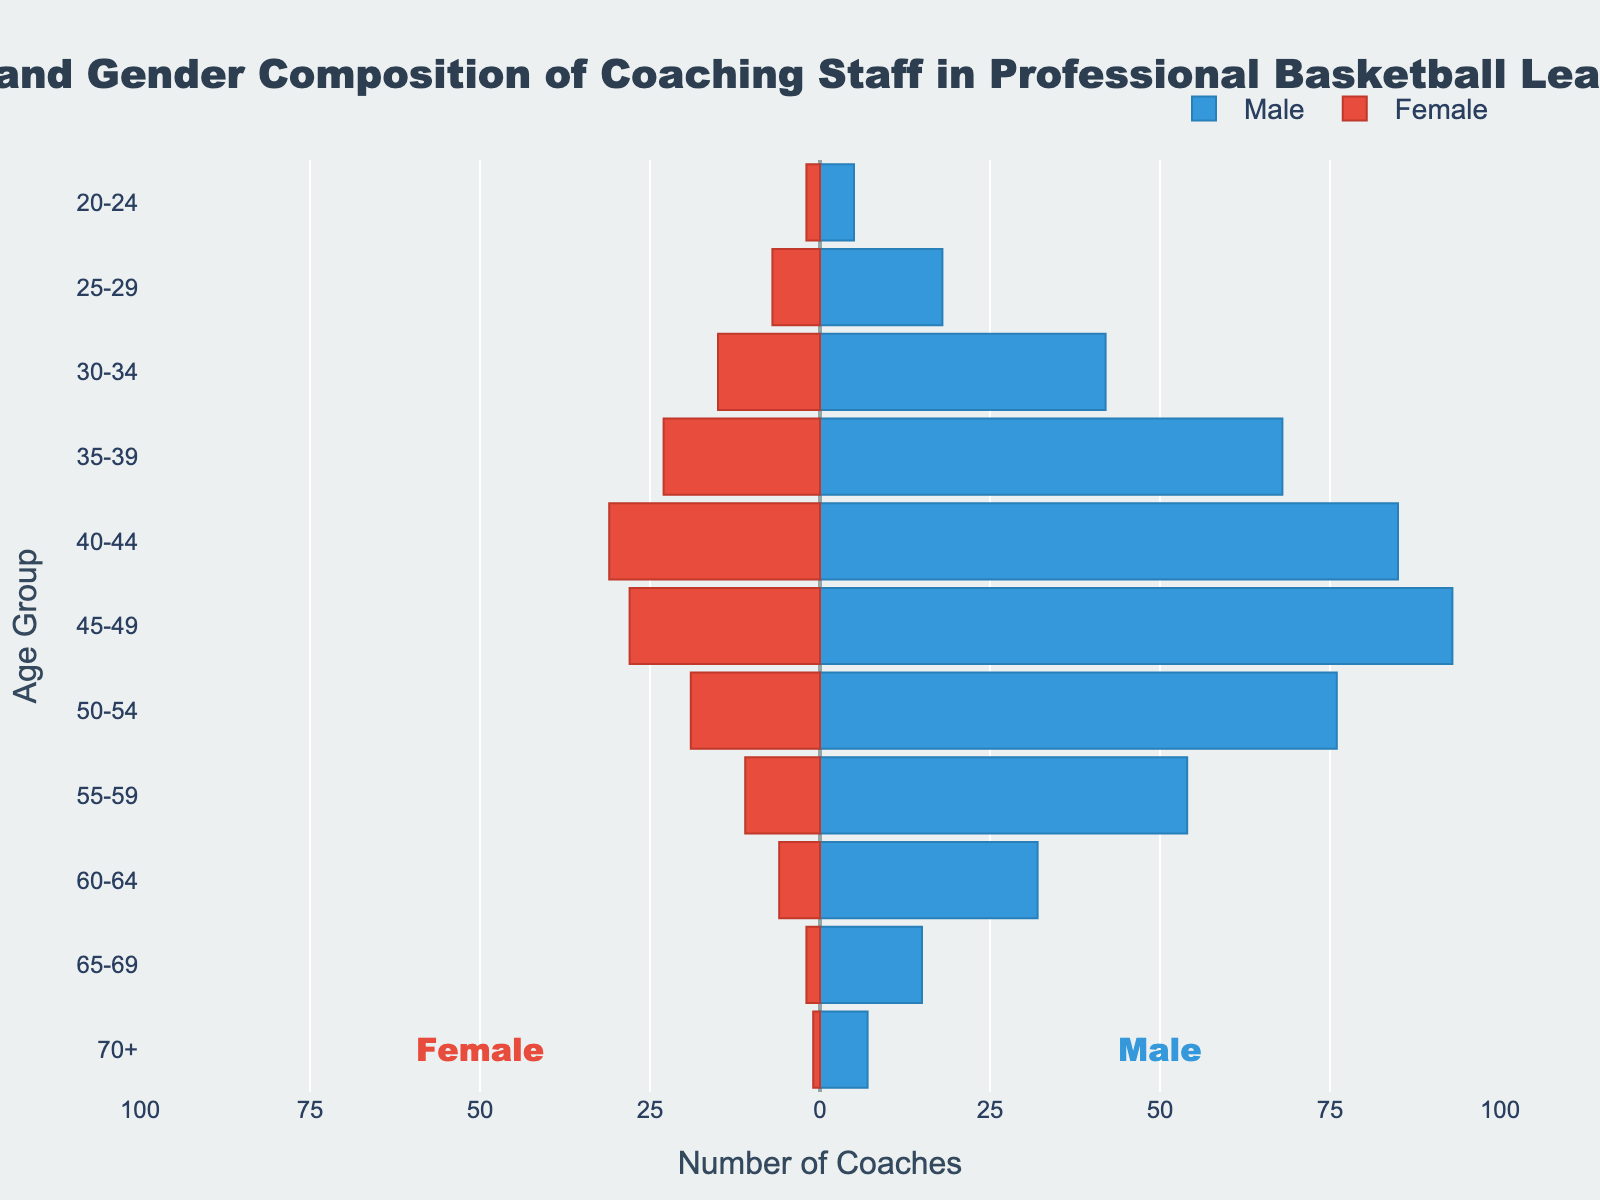What's the title of the figure? The title of the figure is prominently displayed at the top, which reads "Age and Gender Composition of Coaching Staff in Professional Basketball Leagues".
Answer: "Age and Gender Composition of Coaching Staff in Professional Basketball Leagues" Which age group has the highest number of male coaches? By examining the length of the blue bars representing male coaches, the age group 45-49 stands out as having the longest bar, indicating it has the highest number of male coaches.
Answer: 45-49 What is the total number of female coaches in the 40-44 age group? The red bar for female coaches in the 40-44 age group has a value of 31.
Answer: 31 How does the number of female coaches in the 30-34 age group compare to that in the 65-69 age group? The red bar for female coaches is 15 for the 30-34 age group and 2 for the 65-69 age group. The 30-34 age group has a higher number of female coaches.
Answer: The 30-34 age group has more female coaches by 13 Which gender has more coaches in the 50-54 age group? Comparing the lengths of the bars in the 50-54 age group, the blue bar (male) is longer than the red bar (female), indicating there are more male coaches.
Answer: Male What is the total number of male coaches in the 20-24 and 25-29 age groups combined? Adding the male values for the 20-24 and 25-29 age groups: 5 (20-24) + 18 (25-29) = 23.
Answer: 23 On average, how many male and female coaches are there per age group? The total number of male coaches is 495 and female coaches is 145, across 11 age groups. The average per age group is: (495 / 11) ≈ 45 for males and (145 / 11) ≈ 13 for females.
Answer: Approximately 45 male and 13 female Is there any age group where the number of female coaches is below the average number of female coaches per age group? The average number of female coaches per age group is approximately 13. In the 20-24 (2), 25-29 (7), 55-59 (11), 60-64 (6), 65-69 (2), and 70+ (1) age groups, the number of female coaches is below this average.
Answer: Yes, 6 age groups Which age group has the smallest combined total of male and female coaches? Both the blue and red bars for the 70+ age group are shorter than for any other age group, indicating the smallest combined total.
Answer: 70+ In which age group is the representation of male coaches nearly the same as the representation of female coaches? None of the age groups have nearly equal representation of male and female coaches, as there is a significant disparity in all of them.
Answer: None 